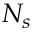Convert formula to latex. <formula><loc_0><loc_0><loc_500><loc_500>N _ { s }</formula> 